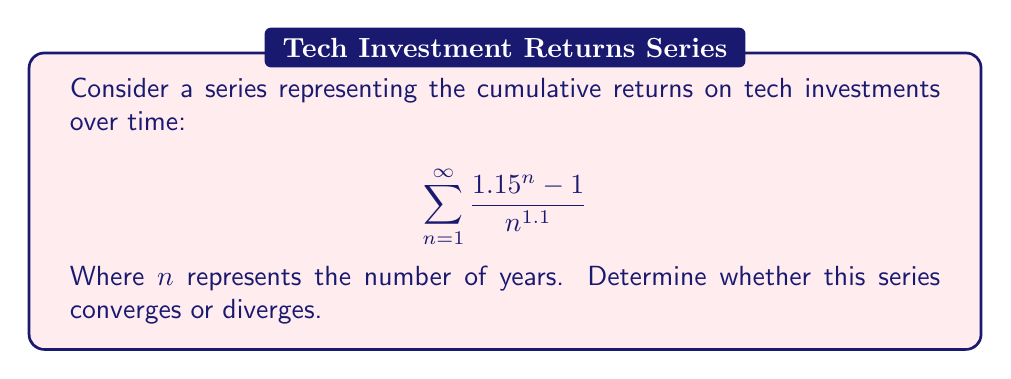Could you help me with this problem? To analyze the convergence of this series, we'll use the limit comparison test with a p-series.

Step 1: Let's define our series term:
$$a_n = \frac{1.15^n - 1}{n^{1.1}}$$

Step 2: Compare this to a p-series term:
$$b_n = \frac{1}{n^{1.1}}$$

Step 3: Calculate the limit of the ratio of these terms as n approaches infinity:

$$\lim_{n \to \infty} \frac{a_n}{b_n} = \lim_{n \to \infty} \frac{1.15^n - 1}{n^{1.1}} \cdot \frac{n^{1.1}}{1} = \lim_{n \to \infty} (1.15^n - 1)$$

Step 4: As $n$ approaches infinity, $1.15^n$ grows without bound, so:

$$\lim_{n \to \infty} \frac{a_n}{b_n} = \infty$$

Step 5: Since this limit is infinite and greater than zero, by the limit comparison test, our series $\sum a_n$ diverges if and only if $\sum b_n$ diverges.

Step 6: $\sum b_n = \sum \frac{1}{n^{1.1}}$ is a p-series with $p = 1.1 > 1$, which converges.

Step 7: However, since $\lim_{n \to \infty} \frac{a_n}{b_n} = \infty$, our original series $\sum a_n$ must diverge.
Answer: The series diverges. 